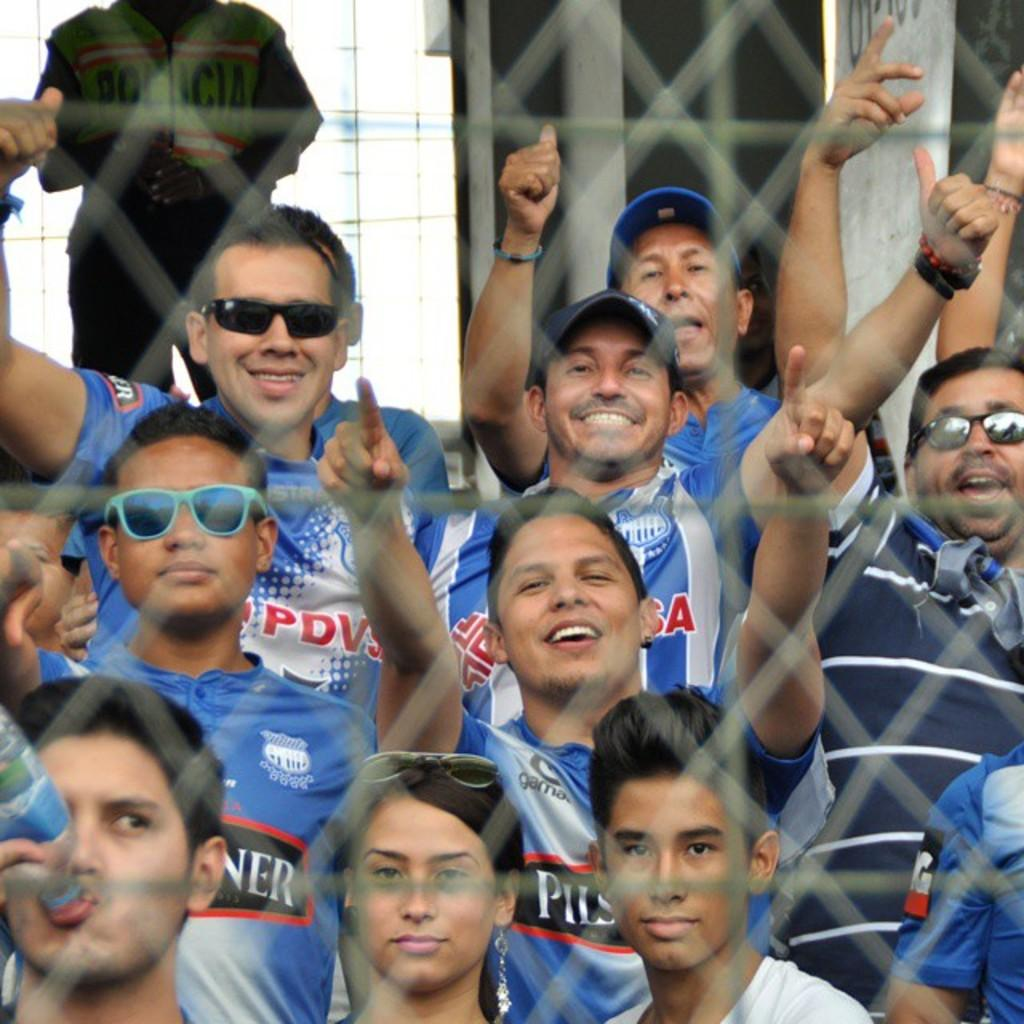What can be seen in the image? There are people standing in the image. Where are the people standing? The people are standing on the floor. What is in front of the people? There is a metal fence in front of the people. What type of pail is being used by the beginner in the image? There is no pail or beginner present in the image. 